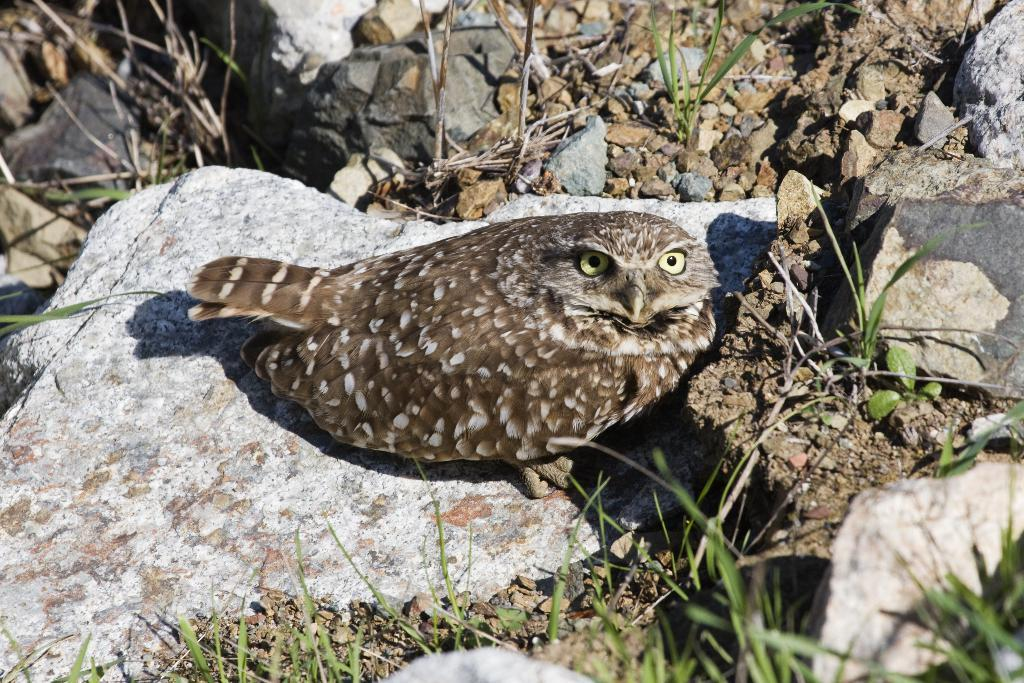What type of animal is in the image? There is an owl in the image. Where is the owl located? The owl is on the ground. What can be seen in the background of the image? There are stones and grass visible in the background of the image. What type of pencil is the owl using to write in the image? There is no pencil present in the image, and the owl is not writing. 